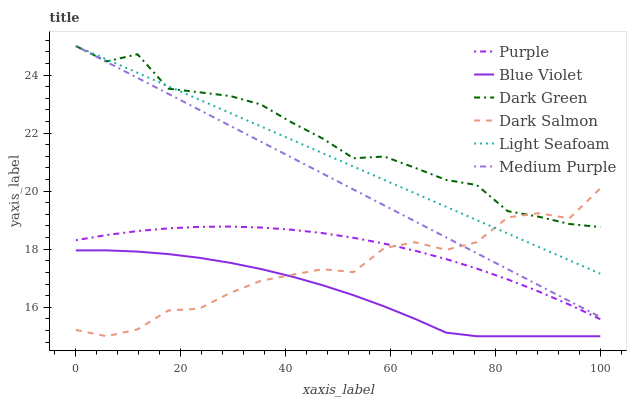Does Blue Violet have the minimum area under the curve?
Answer yes or no. Yes. Does Dark Green have the maximum area under the curve?
Answer yes or no. Yes. Does Dark Salmon have the minimum area under the curve?
Answer yes or no. No. Does Dark Salmon have the maximum area under the curve?
Answer yes or no. No. Is Light Seafoam the smoothest?
Answer yes or no. Yes. Is Dark Salmon the roughest?
Answer yes or no. Yes. Is Medium Purple the smoothest?
Answer yes or no. No. Is Medium Purple the roughest?
Answer yes or no. No. Does Dark Salmon have the lowest value?
Answer yes or no. Yes. Does Medium Purple have the lowest value?
Answer yes or no. No. Does Dark Green have the highest value?
Answer yes or no. Yes. Does Dark Salmon have the highest value?
Answer yes or no. No. Is Blue Violet less than Dark Green?
Answer yes or no. Yes. Is Light Seafoam greater than Blue Violet?
Answer yes or no. Yes. Does Dark Green intersect Medium Purple?
Answer yes or no. Yes. Is Dark Green less than Medium Purple?
Answer yes or no. No. Is Dark Green greater than Medium Purple?
Answer yes or no. No. Does Blue Violet intersect Dark Green?
Answer yes or no. No. 